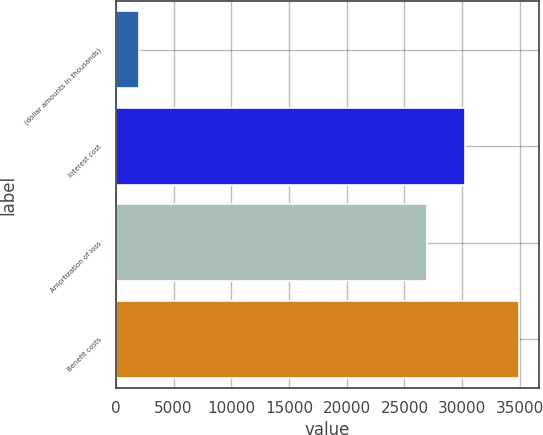Convert chart. <chart><loc_0><loc_0><loc_500><loc_500><bar_chart><fcel>(dollar amounts in thousands)<fcel>Interest cost<fcel>Amortization of loss<fcel>Benefit costs<nl><fcel>2012<fcel>30249.2<fcel>26956<fcel>34944<nl></chart> 